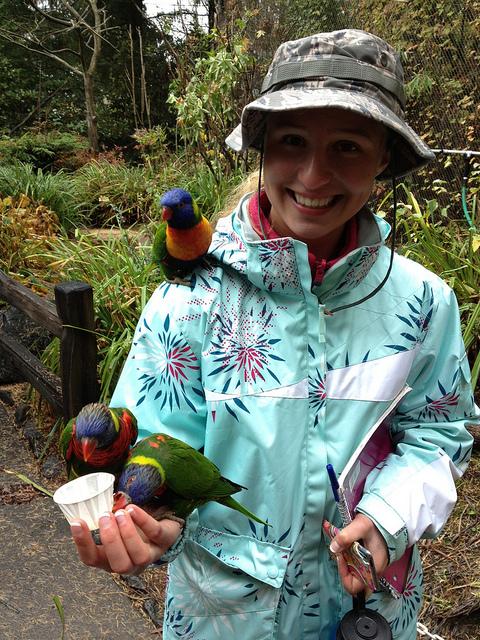What is the lady holding in her right hand?
Keep it brief. Paper cup. Is she holding birds?
Concise answer only. Yes. Are those birds pets?
Short answer required. No. How many birds are on the lady?
Keep it brief. 3. 